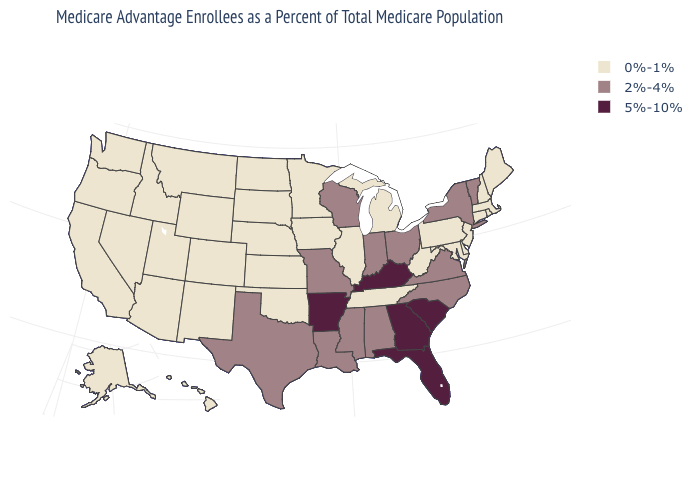Name the states that have a value in the range 0%-1%?
Give a very brief answer. Alaska, Arizona, California, Colorado, Connecticut, Delaware, Hawaii, Iowa, Idaho, Illinois, Kansas, Massachusetts, Maryland, Maine, Michigan, Minnesota, Montana, North Dakota, Nebraska, New Hampshire, New Jersey, New Mexico, Nevada, Oklahoma, Oregon, Pennsylvania, Rhode Island, South Dakota, Tennessee, Utah, Washington, West Virginia, Wyoming. What is the value of Colorado?
Write a very short answer. 0%-1%. Name the states that have a value in the range 0%-1%?
Give a very brief answer. Alaska, Arizona, California, Colorado, Connecticut, Delaware, Hawaii, Iowa, Idaho, Illinois, Kansas, Massachusetts, Maryland, Maine, Michigan, Minnesota, Montana, North Dakota, Nebraska, New Hampshire, New Jersey, New Mexico, Nevada, Oklahoma, Oregon, Pennsylvania, Rhode Island, South Dakota, Tennessee, Utah, Washington, West Virginia, Wyoming. Name the states that have a value in the range 0%-1%?
Short answer required. Alaska, Arizona, California, Colorado, Connecticut, Delaware, Hawaii, Iowa, Idaho, Illinois, Kansas, Massachusetts, Maryland, Maine, Michigan, Minnesota, Montana, North Dakota, Nebraska, New Hampshire, New Jersey, New Mexico, Nevada, Oklahoma, Oregon, Pennsylvania, Rhode Island, South Dakota, Tennessee, Utah, Washington, West Virginia, Wyoming. Among the states that border New Mexico , does Texas have the highest value?
Give a very brief answer. Yes. Name the states that have a value in the range 5%-10%?
Keep it brief. Arkansas, Florida, Georgia, Kentucky, South Carolina. What is the value of Maryland?
Concise answer only. 0%-1%. Does the map have missing data?
Quick response, please. No. What is the value of Vermont?
Concise answer only. 2%-4%. Does Vermont have the lowest value in the Northeast?
Quick response, please. No. Does New Hampshire have the highest value in the USA?
Be succinct. No. Does South Dakota have the highest value in the MidWest?
Be succinct. No. Does Massachusetts have the same value as Georgia?
Write a very short answer. No. Does Georgia have the highest value in the South?
Keep it brief. Yes. What is the highest value in the USA?
Short answer required. 5%-10%. 